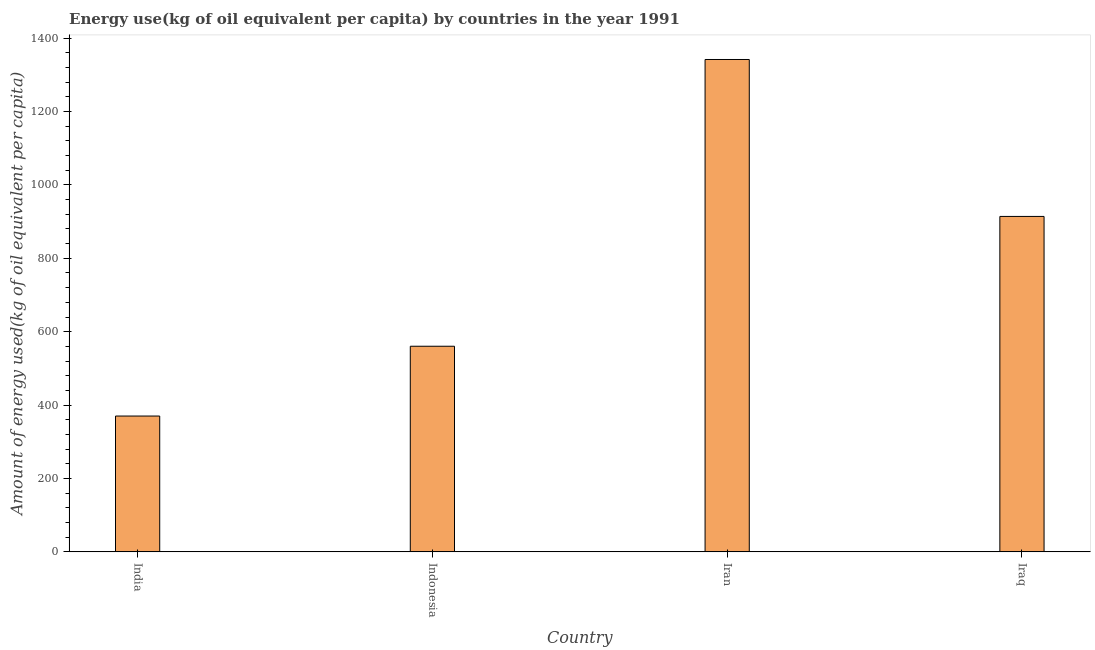What is the title of the graph?
Offer a terse response. Energy use(kg of oil equivalent per capita) by countries in the year 1991. What is the label or title of the X-axis?
Your response must be concise. Country. What is the label or title of the Y-axis?
Ensure brevity in your answer.  Amount of energy used(kg of oil equivalent per capita). What is the amount of energy used in Iran?
Your answer should be compact. 1341.72. Across all countries, what is the maximum amount of energy used?
Your answer should be very brief. 1341.72. Across all countries, what is the minimum amount of energy used?
Keep it short and to the point. 370.16. In which country was the amount of energy used maximum?
Make the answer very short. Iran. What is the sum of the amount of energy used?
Ensure brevity in your answer.  3186.27. What is the difference between the amount of energy used in India and Iran?
Your response must be concise. -971.56. What is the average amount of energy used per country?
Give a very brief answer. 796.57. What is the median amount of energy used?
Provide a succinct answer. 737.19. What is the ratio of the amount of energy used in Indonesia to that in Iraq?
Offer a terse response. 0.61. Is the amount of energy used in Indonesia less than that in Iraq?
Keep it short and to the point. Yes. Is the difference between the amount of energy used in Indonesia and Iran greater than the difference between any two countries?
Keep it short and to the point. No. What is the difference between the highest and the second highest amount of energy used?
Your answer should be compact. 427.66. What is the difference between the highest and the lowest amount of energy used?
Provide a succinct answer. 971.56. In how many countries, is the amount of energy used greater than the average amount of energy used taken over all countries?
Your response must be concise. 2. How many bars are there?
Your answer should be compact. 4. Are all the bars in the graph horizontal?
Your response must be concise. No. What is the Amount of energy used(kg of oil equivalent per capita) in India?
Offer a terse response. 370.16. What is the Amount of energy used(kg of oil equivalent per capita) of Indonesia?
Your response must be concise. 560.33. What is the Amount of energy used(kg of oil equivalent per capita) of Iran?
Your response must be concise. 1341.72. What is the Amount of energy used(kg of oil equivalent per capita) in Iraq?
Provide a short and direct response. 914.06. What is the difference between the Amount of energy used(kg of oil equivalent per capita) in India and Indonesia?
Keep it short and to the point. -190.16. What is the difference between the Amount of energy used(kg of oil equivalent per capita) in India and Iran?
Offer a terse response. -971.56. What is the difference between the Amount of energy used(kg of oil equivalent per capita) in India and Iraq?
Give a very brief answer. -543.89. What is the difference between the Amount of energy used(kg of oil equivalent per capita) in Indonesia and Iran?
Your response must be concise. -781.39. What is the difference between the Amount of energy used(kg of oil equivalent per capita) in Indonesia and Iraq?
Offer a terse response. -353.73. What is the difference between the Amount of energy used(kg of oil equivalent per capita) in Iran and Iraq?
Make the answer very short. 427.66. What is the ratio of the Amount of energy used(kg of oil equivalent per capita) in India to that in Indonesia?
Ensure brevity in your answer.  0.66. What is the ratio of the Amount of energy used(kg of oil equivalent per capita) in India to that in Iran?
Give a very brief answer. 0.28. What is the ratio of the Amount of energy used(kg of oil equivalent per capita) in India to that in Iraq?
Make the answer very short. 0.41. What is the ratio of the Amount of energy used(kg of oil equivalent per capita) in Indonesia to that in Iran?
Your answer should be compact. 0.42. What is the ratio of the Amount of energy used(kg of oil equivalent per capita) in Indonesia to that in Iraq?
Your answer should be very brief. 0.61. What is the ratio of the Amount of energy used(kg of oil equivalent per capita) in Iran to that in Iraq?
Make the answer very short. 1.47. 